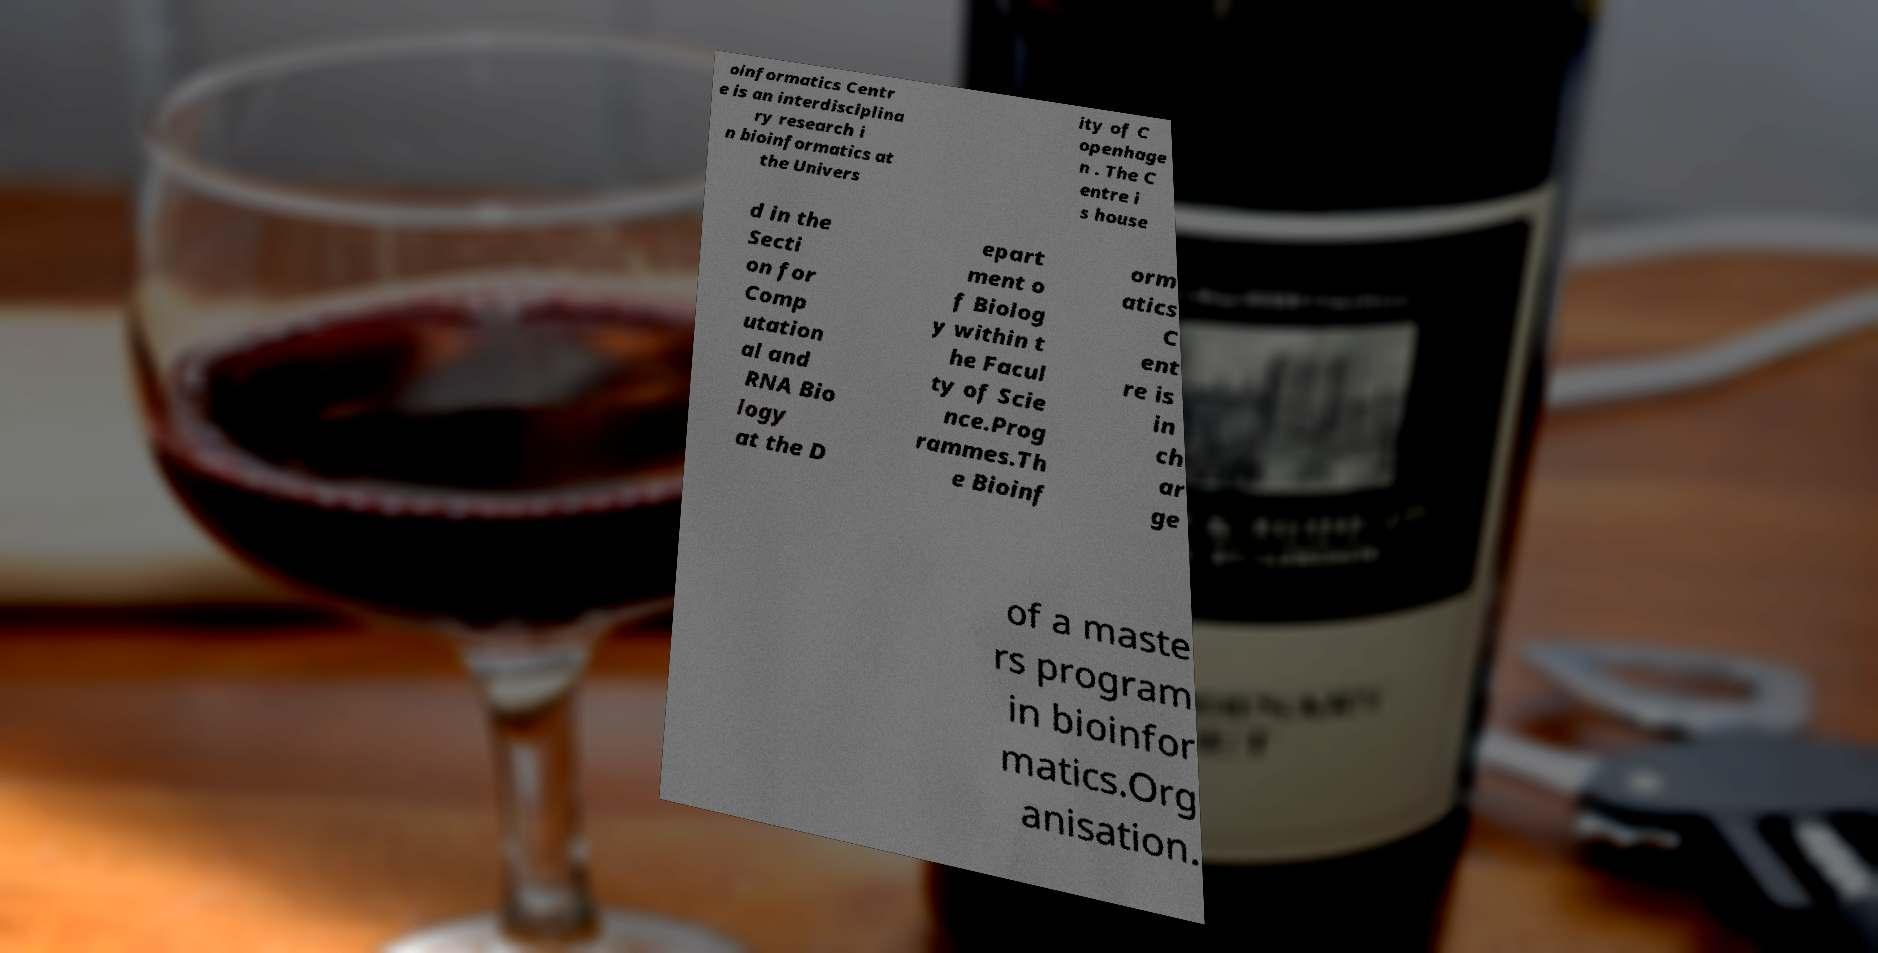For documentation purposes, I need the text within this image transcribed. Could you provide that? oinformatics Centr e is an interdisciplina ry research i n bioinformatics at the Univers ity of C openhage n . The C entre i s house d in the Secti on for Comp utation al and RNA Bio logy at the D epart ment o f Biolog y within t he Facul ty of Scie nce.Prog rammes.Th e Bioinf orm atics C ent re is in ch ar ge of a maste rs program in bioinfor matics.Org anisation. 